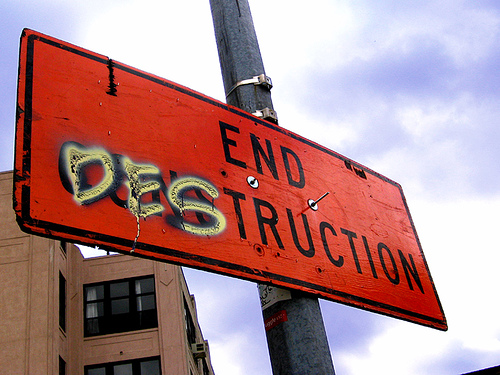<image>Which street sign is bent? I can't tell which street sign is bent from the information provided. It could potentially be the 'end construction' sign. Which street sign is bent? I am not sure which street sign is bent. None of the street signs appear to be bent. 